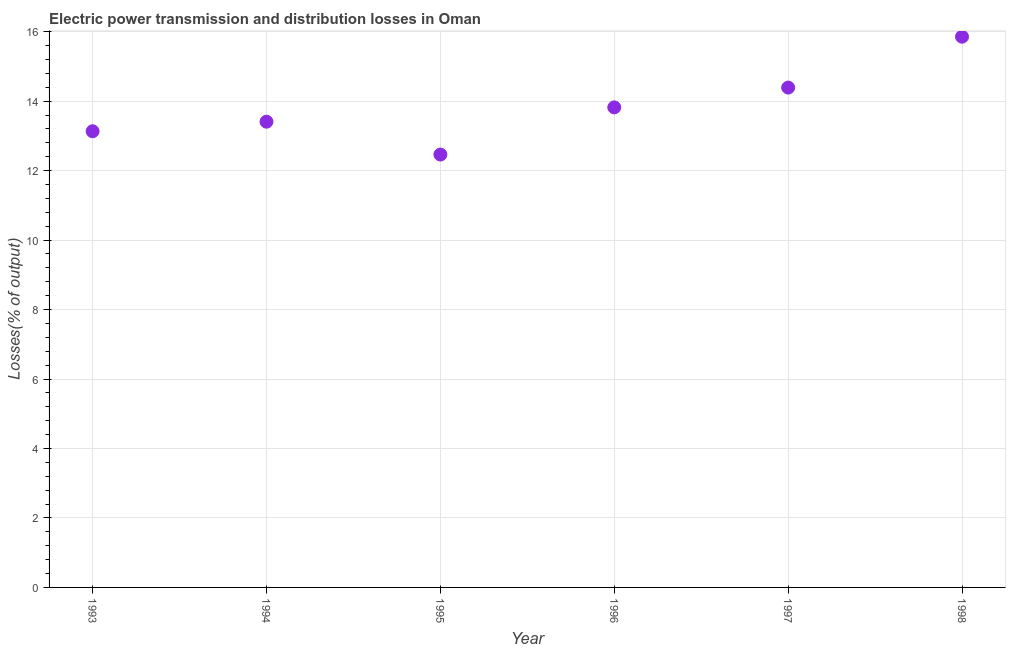What is the electric power transmission and distribution losses in 1994?
Make the answer very short. 13.41. Across all years, what is the maximum electric power transmission and distribution losses?
Your response must be concise. 15.85. Across all years, what is the minimum electric power transmission and distribution losses?
Give a very brief answer. 12.46. In which year was the electric power transmission and distribution losses maximum?
Offer a terse response. 1998. What is the sum of the electric power transmission and distribution losses?
Make the answer very short. 83.06. What is the difference between the electric power transmission and distribution losses in 1997 and 1998?
Your answer should be compact. -1.46. What is the average electric power transmission and distribution losses per year?
Your answer should be very brief. 13.84. What is the median electric power transmission and distribution losses?
Provide a succinct answer. 13.61. In how many years, is the electric power transmission and distribution losses greater than 2 %?
Make the answer very short. 6. What is the ratio of the electric power transmission and distribution losses in 1994 to that in 1995?
Your answer should be compact. 1.08. Is the electric power transmission and distribution losses in 1995 less than that in 1996?
Offer a terse response. Yes. Is the difference between the electric power transmission and distribution losses in 1996 and 1998 greater than the difference between any two years?
Offer a very short reply. No. What is the difference between the highest and the second highest electric power transmission and distribution losses?
Provide a succinct answer. 1.46. Is the sum of the electric power transmission and distribution losses in 1995 and 1997 greater than the maximum electric power transmission and distribution losses across all years?
Ensure brevity in your answer.  Yes. What is the difference between the highest and the lowest electric power transmission and distribution losses?
Provide a succinct answer. 3.39. Does the electric power transmission and distribution losses monotonically increase over the years?
Your response must be concise. No. How many years are there in the graph?
Give a very brief answer. 6. What is the difference between two consecutive major ticks on the Y-axis?
Your answer should be compact. 2. Are the values on the major ticks of Y-axis written in scientific E-notation?
Your answer should be very brief. No. Does the graph contain any zero values?
Offer a very short reply. No. Does the graph contain grids?
Your answer should be compact. Yes. What is the title of the graph?
Give a very brief answer. Electric power transmission and distribution losses in Oman. What is the label or title of the Y-axis?
Your answer should be very brief. Losses(% of output). What is the Losses(% of output) in 1993?
Offer a terse response. 13.13. What is the Losses(% of output) in 1994?
Your response must be concise. 13.41. What is the Losses(% of output) in 1995?
Your answer should be very brief. 12.46. What is the Losses(% of output) in 1996?
Provide a short and direct response. 13.82. What is the Losses(% of output) in 1997?
Your response must be concise. 14.39. What is the Losses(% of output) in 1998?
Your answer should be very brief. 15.85. What is the difference between the Losses(% of output) in 1993 and 1994?
Your answer should be compact. -0.28. What is the difference between the Losses(% of output) in 1993 and 1995?
Provide a short and direct response. 0.67. What is the difference between the Losses(% of output) in 1993 and 1996?
Offer a very short reply. -0.69. What is the difference between the Losses(% of output) in 1993 and 1997?
Offer a terse response. -1.26. What is the difference between the Losses(% of output) in 1993 and 1998?
Make the answer very short. -2.72. What is the difference between the Losses(% of output) in 1994 and 1995?
Your response must be concise. 0.95. What is the difference between the Losses(% of output) in 1994 and 1996?
Offer a terse response. -0.41. What is the difference between the Losses(% of output) in 1994 and 1997?
Your answer should be compact. -0.98. What is the difference between the Losses(% of output) in 1994 and 1998?
Ensure brevity in your answer.  -2.45. What is the difference between the Losses(% of output) in 1995 and 1996?
Make the answer very short. -1.36. What is the difference between the Losses(% of output) in 1995 and 1997?
Ensure brevity in your answer.  -1.93. What is the difference between the Losses(% of output) in 1995 and 1998?
Provide a short and direct response. -3.39. What is the difference between the Losses(% of output) in 1996 and 1997?
Offer a very short reply. -0.57. What is the difference between the Losses(% of output) in 1996 and 1998?
Provide a short and direct response. -2.03. What is the difference between the Losses(% of output) in 1997 and 1998?
Ensure brevity in your answer.  -1.46. What is the ratio of the Losses(% of output) in 1993 to that in 1994?
Your answer should be very brief. 0.98. What is the ratio of the Losses(% of output) in 1993 to that in 1995?
Keep it short and to the point. 1.05. What is the ratio of the Losses(% of output) in 1993 to that in 1996?
Give a very brief answer. 0.95. What is the ratio of the Losses(% of output) in 1993 to that in 1998?
Keep it short and to the point. 0.83. What is the ratio of the Losses(% of output) in 1994 to that in 1995?
Keep it short and to the point. 1.08. What is the ratio of the Losses(% of output) in 1994 to that in 1997?
Give a very brief answer. 0.93. What is the ratio of the Losses(% of output) in 1994 to that in 1998?
Offer a terse response. 0.85. What is the ratio of the Losses(% of output) in 1995 to that in 1996?
Offer a very short reply. 0.9. What is the ratio of the Losses(% of output) in 1995 to that in 1997?
Offer a very short reply. 0.87. What is the ratio of the Losses(% of output) in 1995 to that in 1998?
Your answer should be compact. 0.79. What is the ratio of the Losses(% of output) in 1996 to that in 1997?
Your answer should be compact. 0.96. What is the ratio of the Losses(% of output) in 1996 to that in 1998?
Offer a terse response. 0.87. What is the ratio of the Losses(% of output) in 1997 to that in 1998?
Provide a succinct answer. 0.91. 